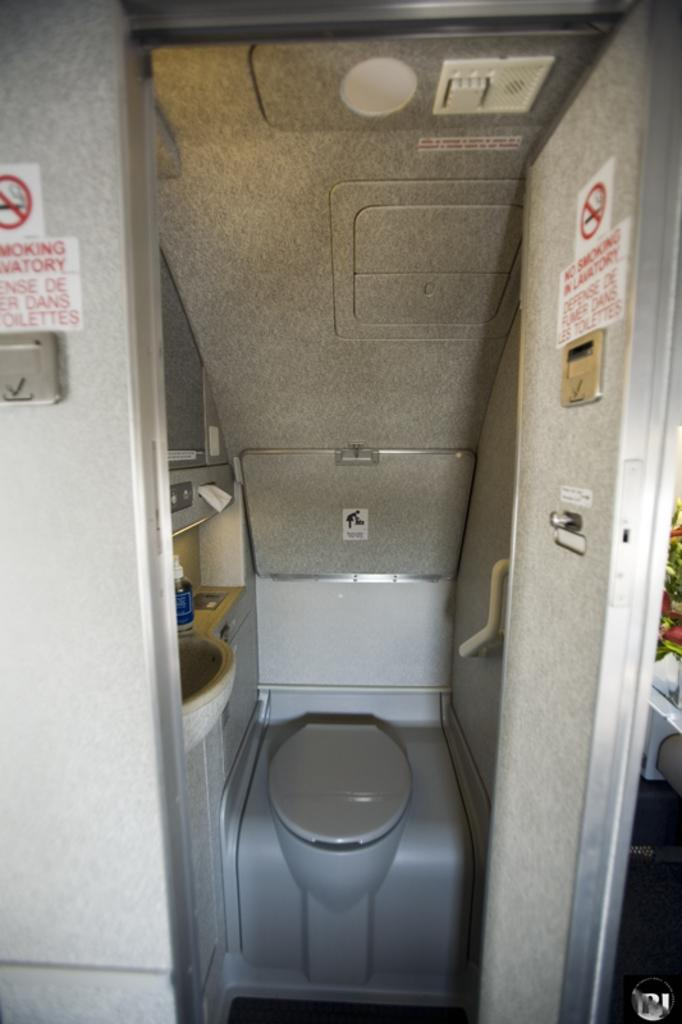<image>
Create a compact narrative representing the image presented. Bathroom on an airplane that has a sign which says "No Smoking In Lavatory". 